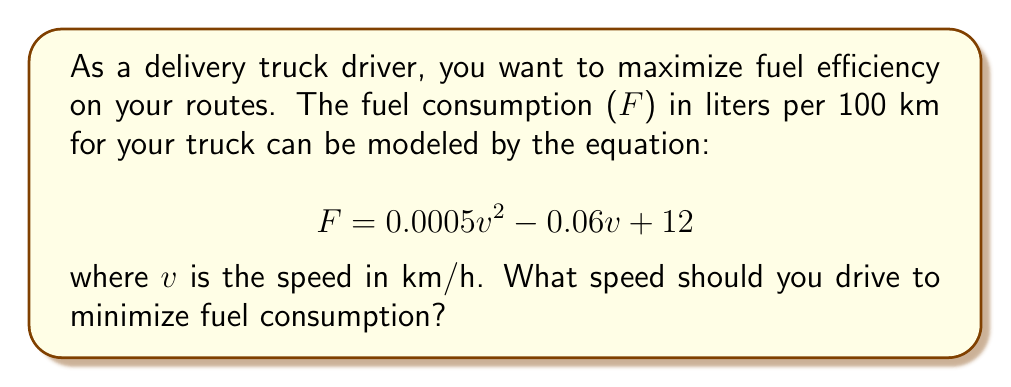Solve this math problem. To find the optimal speed for fuel efficiency, we need to minimize the fuel consumption function. This can be done by finding the minimum point of the quadratic function.

1. The fuel consumption function is a quadratic equation in the form:
   $$F = av^2 + bv + c$$
   where $a = 0.0005$, $b = -0.06$, and $c = 12$

2. For a quadratic function, the minimum (or maximum) occurs at the vertex. The x-coordinate of the vertex can be found using the formula:
   $$v = -\frac{b}{2a}$$

3. Substituting our values:
   $$v = -\frac{-0.06}{2(0.0005)} = \frac{0.06}{0.001} = 60$$

4. To confirm this is a minimum (not a maximum), we can check that $a > 0$, which it is (0.0005 > 0).

5. Therefore, the optimal speed for fuel efficiency is 60 km/h.

6. We can verify this by calculating fuel consumption at speeds slightly above and below 60 km/h:

   At 59 km/h: $F = 0.0005(59)^2 - 0.06(59) + 12 = 10.2955$ L/100km
   At 60 km/h: $F = 0.0005(60)^2 - 0.06(60) + 12 = 10.2900$ L/100km
   At 61 km/h: $F = 0.0005(61)^2 - 0.06(61) + 12 = 10.2945$ L/100km

   This confirms that 60 km/h gives the lowest fuel consumption.
Answer: The optimal speed for fuel efficiency is 60 km/h. 